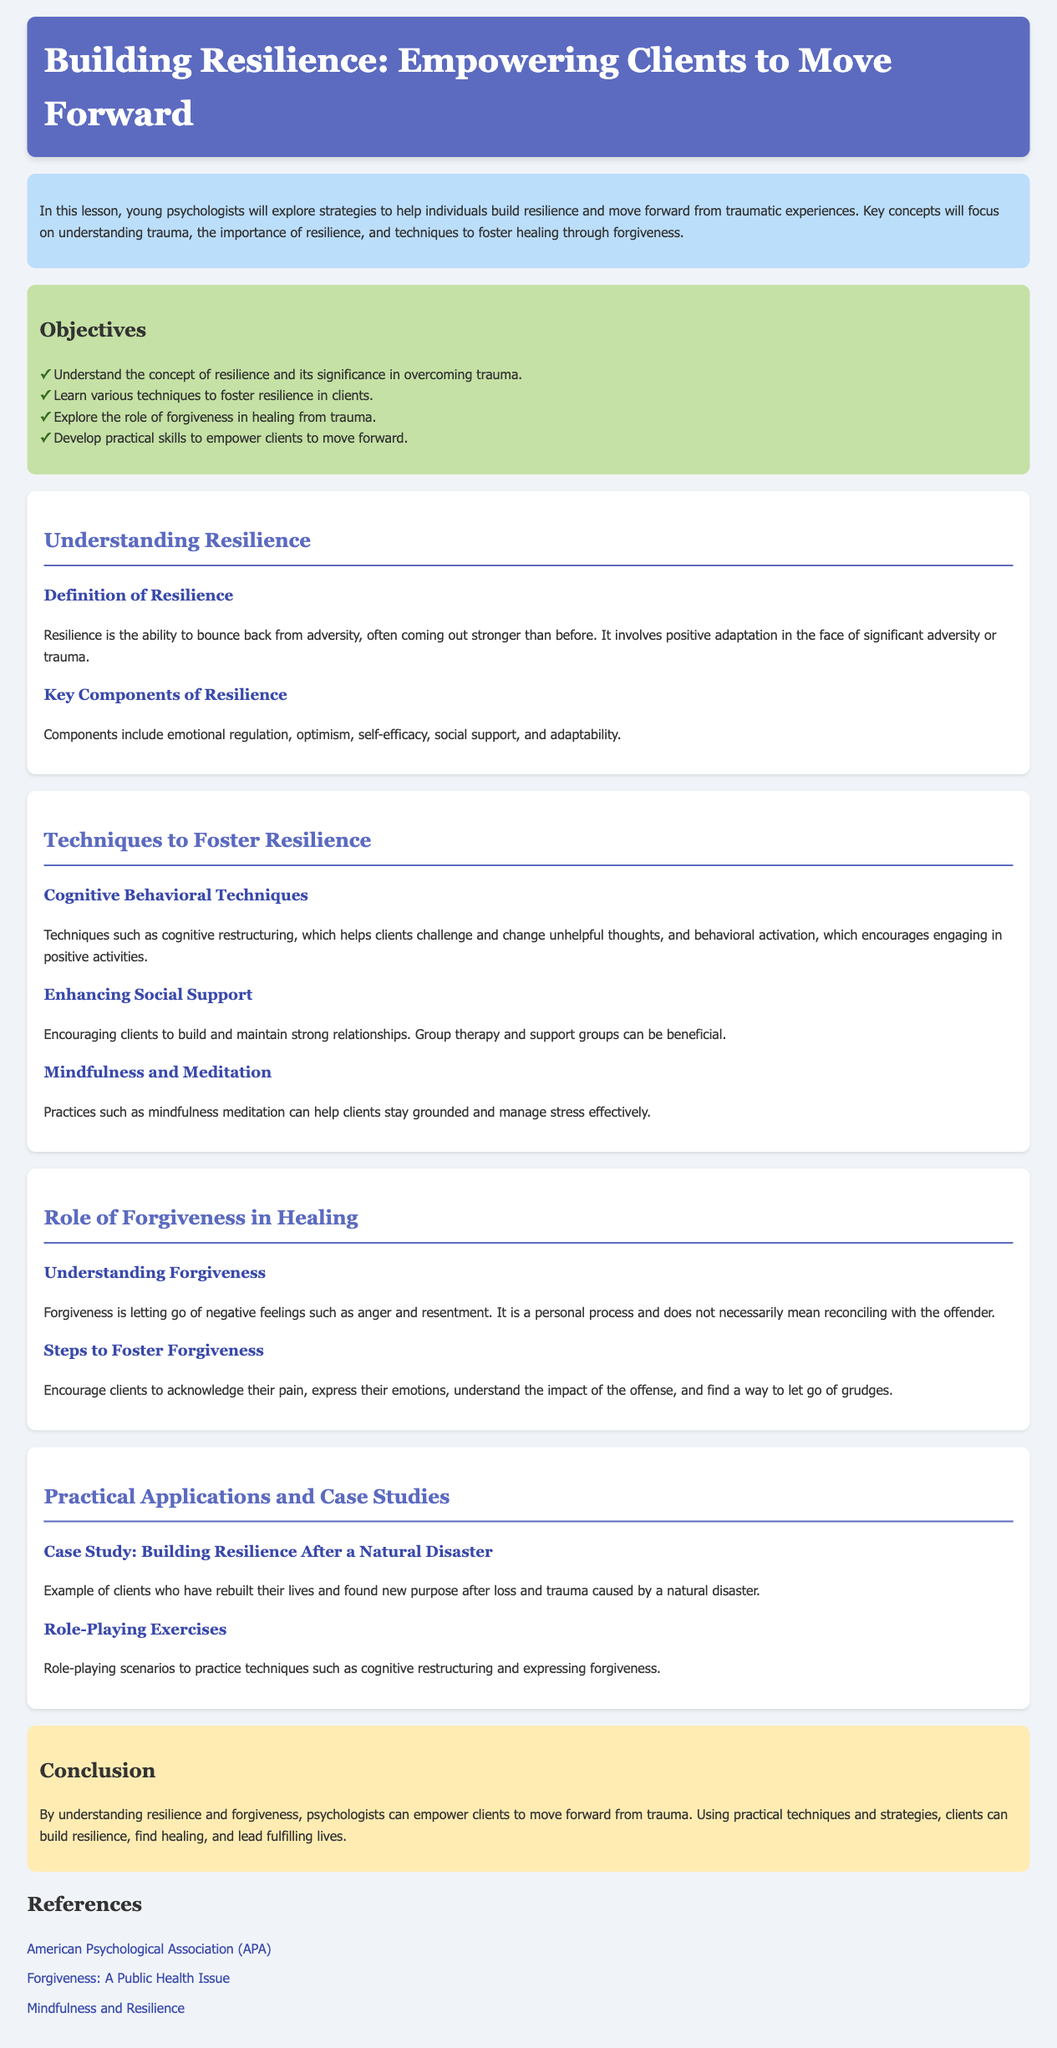what is the title of the lesson plan? The title of the lesson plan is presented at the top of the document.
Answer: Building Resilience: Empowering Clients to Move Forward what are the key components of resilience? The key components of resilience are listed in the discussion about resilience within the document.
Answer: Emotional regulation, optimism, self-efficacy, social support, and adaptability how many objectives are listed in the lesson plan? The number of objectives is indicated in the objectives section of the document.
Answer: Four what technique helps clients challenge unhelpful thoughts? The technique that helps clients challenge unhelpful thoughts is mentioned under techniques to foster resilience.
Answer: Cognitive restructuring what is meant by forgiveness according to the document? The document provides a definition of forgiveness in the role of forgiveness section.
Answer: Letting go of negative feelings such as anger and resentment what type of exercise is suggested for practicing forgiveness? The document describes specific activities for practicing forgiveness as part of practical applications.
Answer: Role-playing exercises 